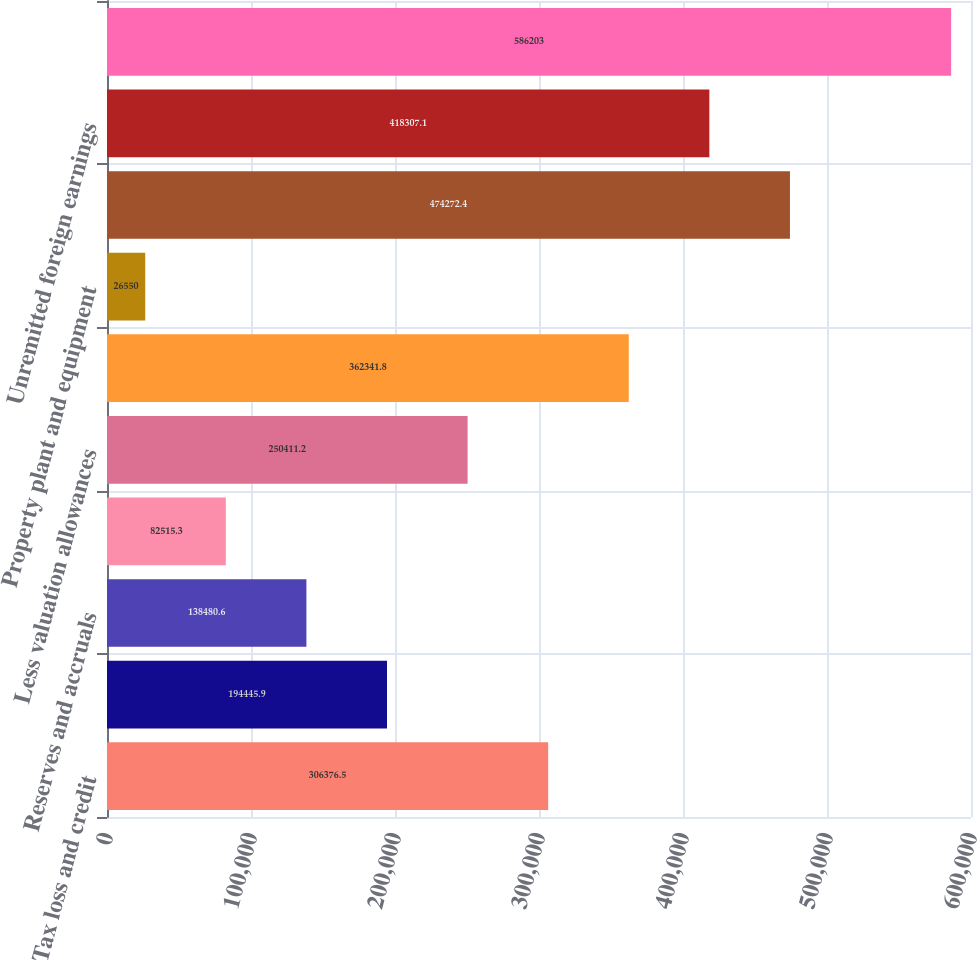Convert chart. <chart><loc_0><loc_0><loc_500><loc_500><bar_chart><fcel>Tax loss and credit<fcel>Pension<fcel>Reserves and accruals<fcel>Other<fcel>Less valuation allowances<fcel>Total deferred tax assets<fcel>Property plant and equipment<fcel>Intangibles - stock<fcel>Unremitted foreign earnings<fcel>Total deferred tax liabilities<nl><fcel>306376<fcel>194446<fcel>138481<fcel>82515.3<fcel>250411<fcel>362342<fcel>26550<fcel>474272<fcel>418307<fcel>586203<nl></chart> 